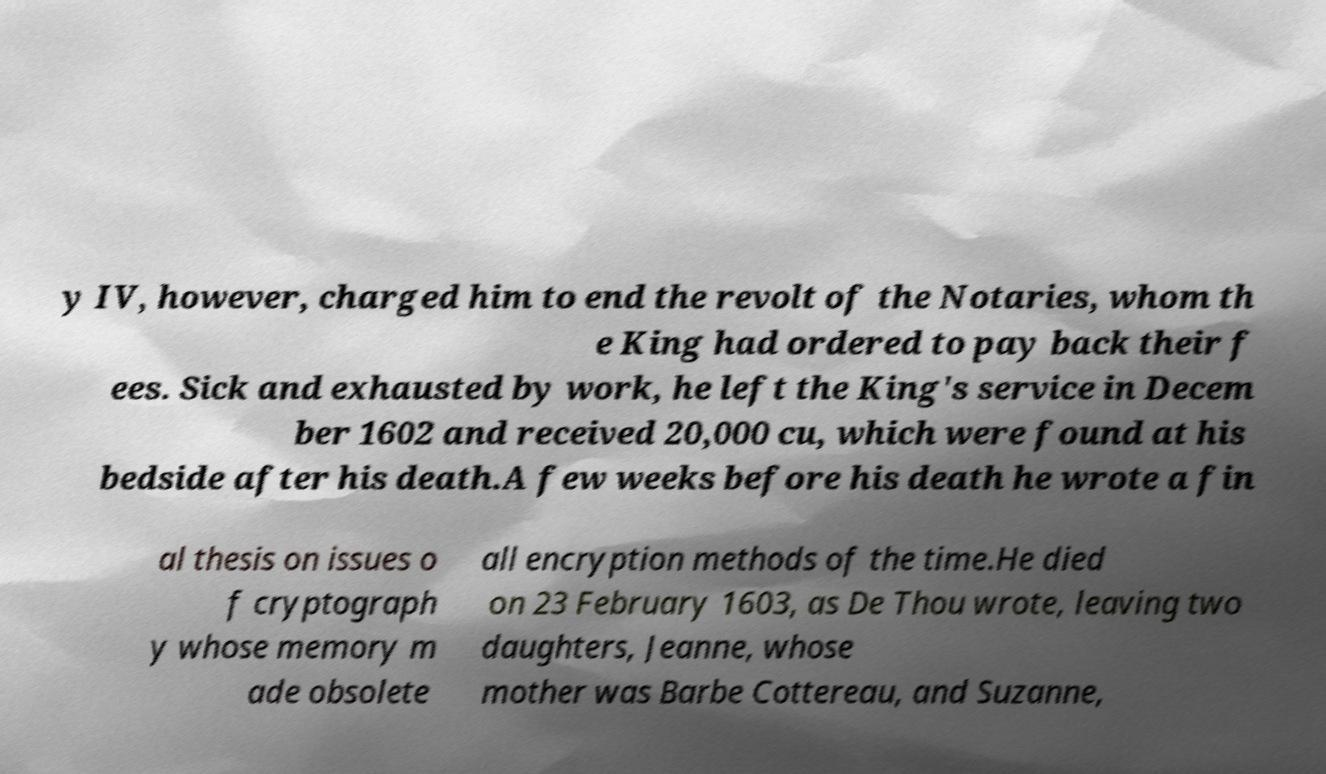Please identify and transcribe the text found in this image. y IV, however, charged him to end the revolt of the Notaries, whom th e King had ordered to pay back their f ees. Sick and exhausted by work, he left the King's service in Decem ber 1602 and received 20,000 cu, which were found at his bedside after his death.A few weeks before his death he wrote a fin al thesis on issues o f cryptograph y whose memory m ade obsolete all encryption methods of the time.He died on 23 February 1603, as De Thou wrote, leaving two daughters, Jeanne, whose mother was Barbe Cottereau, and Suzanne, 